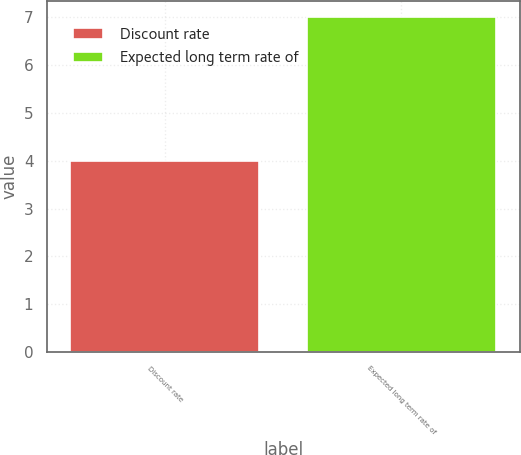Convert chart. <chart><loc_0><loc_0><loc_500><loc_500><bar_chart><fcel>Discount rate<fcel>Expected long term rate of<nl><fcel>4<fcel>7<nl></chart> 